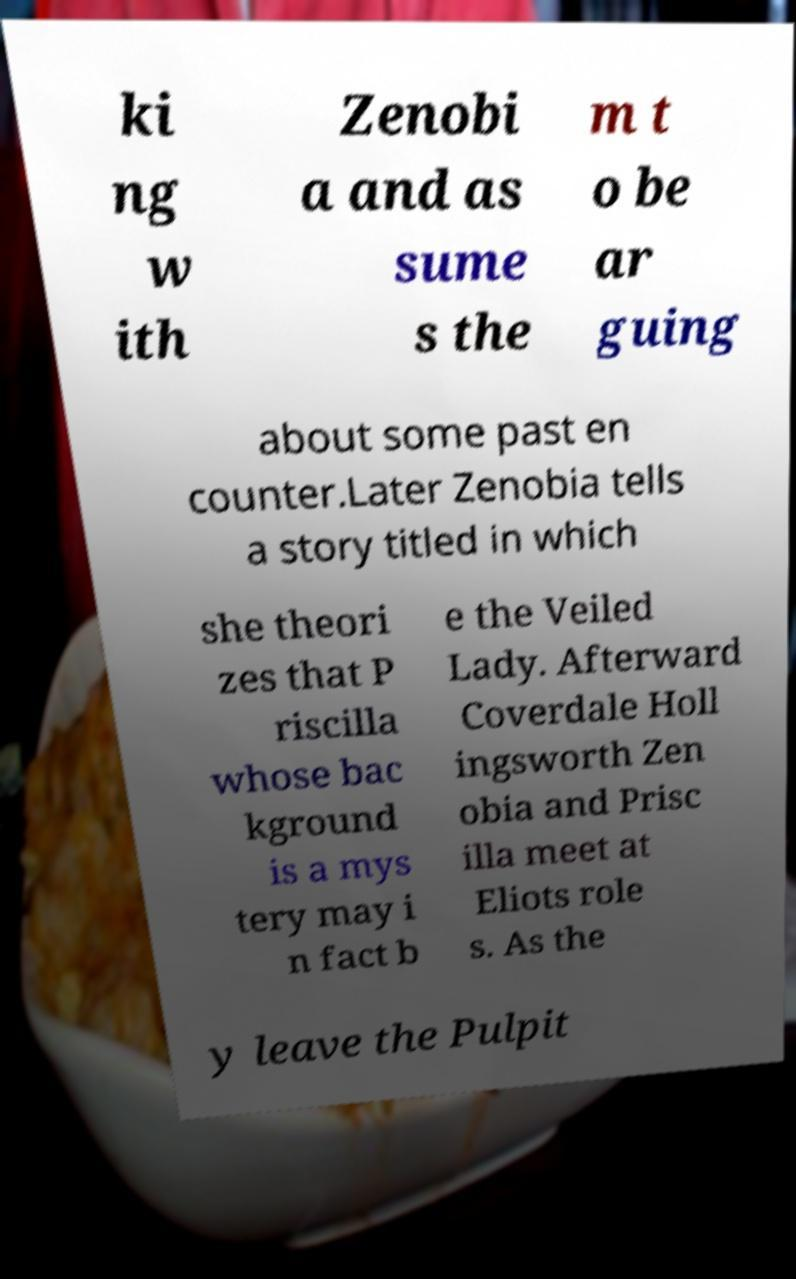Please read and relay the text visible in this image. What does it say? ki ng w ith Zenobi a and as sume s the m t o be ar guing about some past en counter.Later Zenobia tells a story titled in which she theori zes that P riscilla whose bac kground is a mys tery may i n fact b e the Veiled Lady. Afterward Coverdale Holl ingsworth Zen obia and Prisc illa meet at Eliots role s. As the y leave the Pulpit 